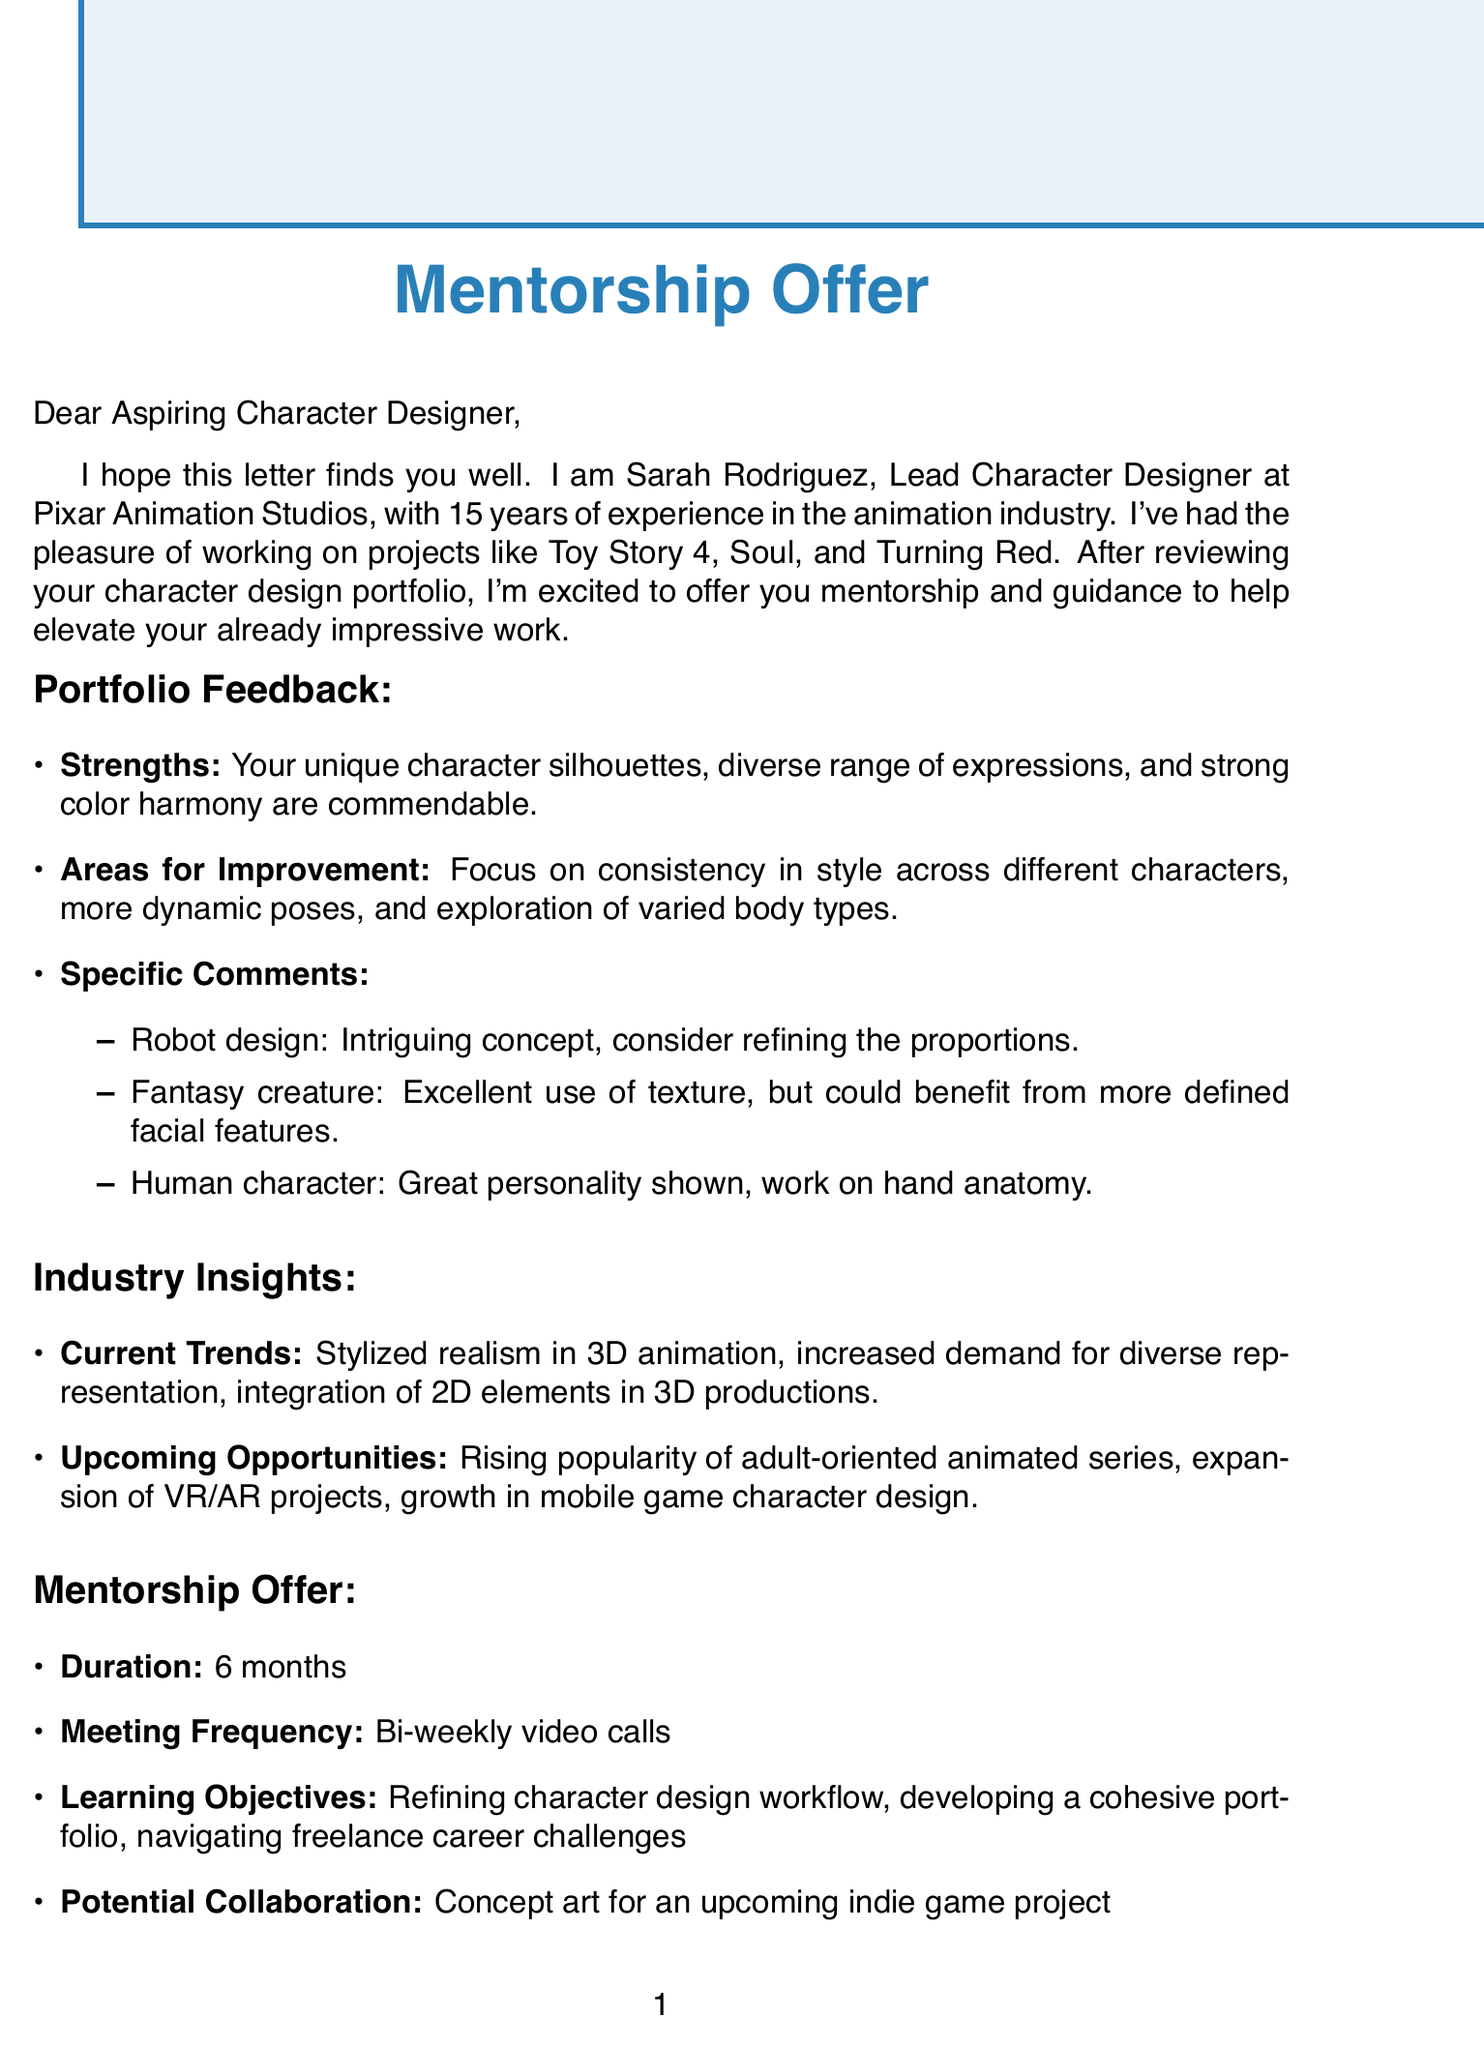What is the name of the mentor? The mentor's name is provided in the document.
Answer: Sarah Rodriguez Which studio does the mentor work for? The document specifies the mentor's workplace.
Answer: Pixar Animation Studios How many years of experience does the mentor have? The experience of the mentor is stated in the document.
Answer: 15 years What is a strength of your portfolio according to the mentor? The document highlights strengths from the portfolio.
Answer: Unique character silhouettes What area should you improve in your character design? The document lists areas for improvement.
Answer: Consistency in style across different characters How long is the proposed mentorship duration? The duration of the mentorship is specified in the document.
Answer: 6 months What type of collaboration is mentioned in the mentorship offer? The document outlines potential collaboration.
Answer: Concept art for an upcoming indie game project What is one current trend in the animation industry? The document mentions current industry trends.
Answer: Stylized realism in 3D animation Which book is recommended for character design? The document lists recommended resources, including books.
Answer: Creating Characters with Personality What is the mentor's closing thought? The closing thoughts of the mentor are described in the document.
Answer: Your portfolio shows great potential 